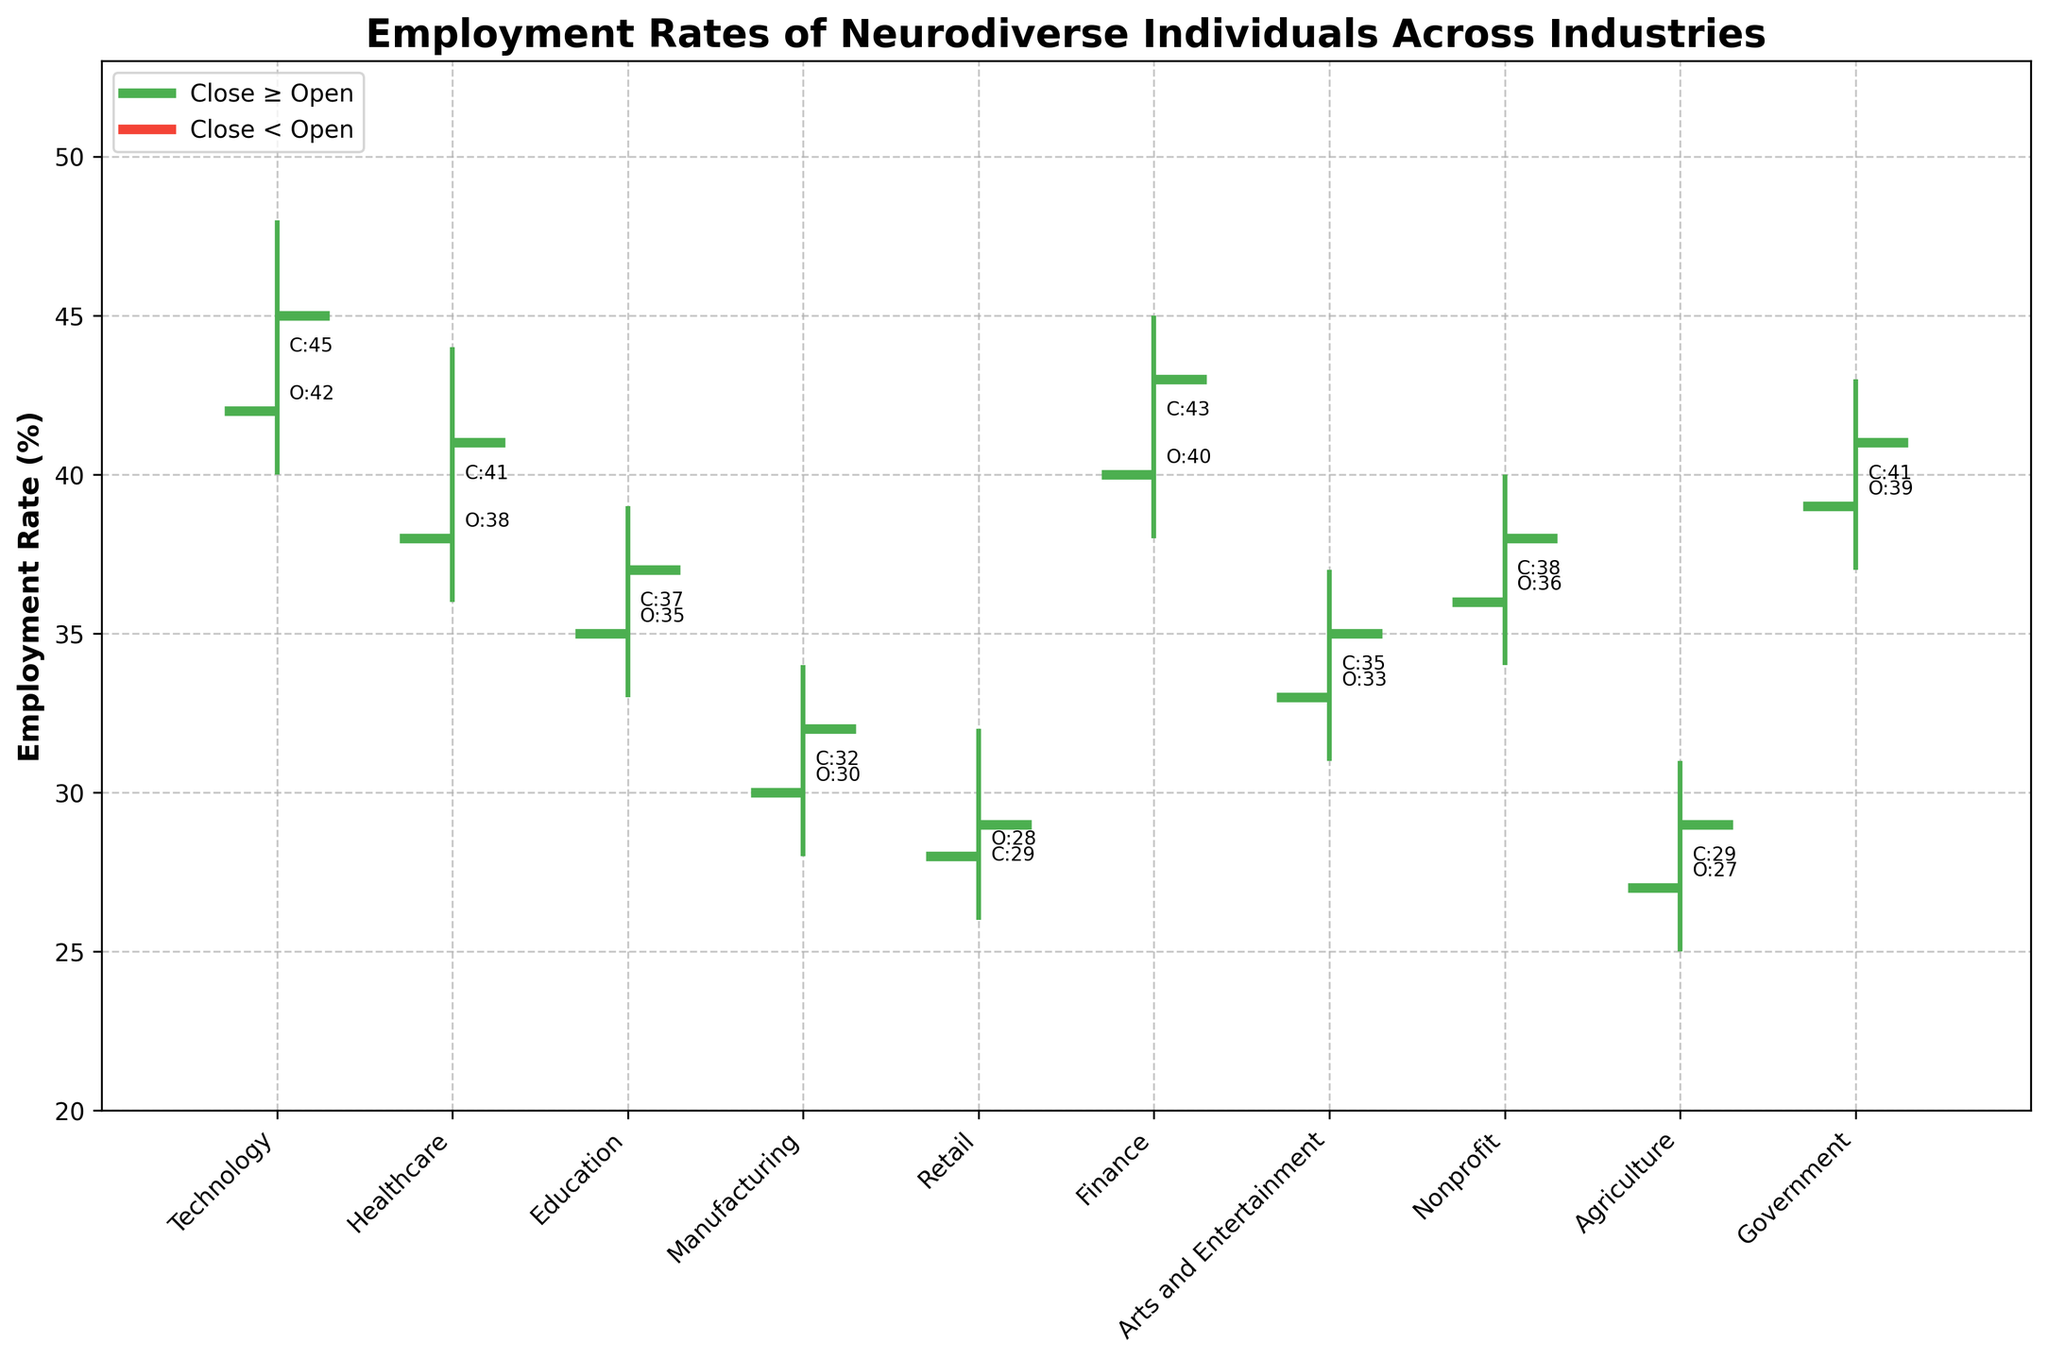What is the title of the figure? The title of the figure is displayed at the top of the chart. It reads "Employment Rates of Neurodiverse Individuals Across Industries".
Answer: Employment Rates of Neurodiverse Individuals Across Industries What is the employment rate range in the Retail industry? To find the range of employment rates for Retail, look at the lowest (Low) and highest (High) points for that industry. The Low is 26 and the High is 32.
Answer: 26 - 32 Which industry experienced the largest spread between its highest and lowest employment rates? Calculate the spreads for each industry by subtracting the Low value from the High value. The spreads are: Technology (48-40=8), Healthcare (44-36=8), Education (39-33=6), Manufacturing (34-28=6), Retail (32-26=6), Finance (45-38=7), Arts and Entertainment (37-31=6), Nonprofit (40-34=6), Agriculture (31-25=6), Government (43-37=6). Two industries, Technology and Healthcare, both have the largest spread of 8.
Answer: Technology and Healthcare Which industry had a higher close rate compared to its open rate? Compare the Open and Close values for each industry. Technology (45 > 42), Healthcare (41 > 38), Finance (43 > 40), Nonprofit (38 > 36), Government (41 > 39). The industries with a higher close rate compared to open are Technology, Healthcare, Finance, Nonprofit, and Government.
Answer: Technology, Healthcare, Finance, Nonprofit, Government What's the average closing employment rate across all industries? The closing rates are: Technology (45), Healthcare (41), Education (37), Manufacturing (32), Retail (29), Finance (43), Arts and Entertainment (35), Nonprofit (38), Agriculture (29), Government (41). Sum these values and divide by the number of industries: (45+41+37+32+29+43+35+38+29+41) / 10 = 370 / 10 = 37.
Answer: 37 Which industry has the lowest opening employment rate? To find the industry with the lowest opening rate, look at the Open column and find the smallest value. The smallest value is 27 for Agriculture.
Answer: Agriculture How many industries have a closing employment rate greater than 40? Look at the Close values and count how many are greater than 40. They are Technology (45), Healthcare (41), Finance (43), and Government (41). There are 4 industries.
Answer: 4 What is the employment rate difference between the opening and closing rates for the Finance industry? Subtract the opening rate from the closing rate for Finance: 43 - 40 = 3.
Answer: 3 In which industries was the closing rate less than the opening rate? Compare the Open and Close values for each industry. They are: Education (37 < 35), Manufacturing (32 < 30), Retail (29 < 28), Arts and Entertainment (35 < 33), Agriculture (29 < 27).
Answer: Education, Manufacturing, Retail, Arts and Entertainment, Agriculture 